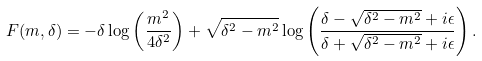Convert formula to latex. <formula><loc_0><loc_0><loc_500><loc_500>F ( m , \delta ) = - \delta \log \left ( \frac { m ^ { 2 } } { 4 \delta ^ { 2 } } \right ) + \sqrt { \delta ^ { 2 } - m ^ { 2 } } \log \left ( \frac { \delta - \sqrt { \delta ^ { 2 } - m ^ { 2 } } + i \epsilon } { \delta + \sqrt { \delta ^ { 2 } - m ^ { 2 } } + i \epsilon } \right ) .</formula> 